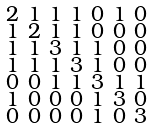<formula> <loc_0><loc_0><loc_500><loc_500>\begin{smallmatrix} 2 & 1 & 1 & 1 & 0 & 1 & 0 \\ 1 & 2 & 1 & 1 & 0 & 0 & 0 \\ 1 & 1 & 3 & 1 & 1 & 0 & 0 \\ 1 & 1 & 1 & 3 & 1 & 0 & 0 \\ 0 & 0 & 1 & 1 & 3 & 1 & 1 \\ 1 & 0 & 0 & 0 & 1 & 3 & 0 \\ 0 & 0 & 0 & 0 & 1 & 0 & 3 \end{smallmatrix}</formula> 